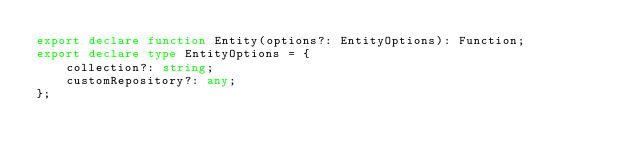<code> <loc_0><loc_0><loc_500><loc_500><_TypeScript_>export declare function Entity(options?: EntityOptions): Function;
export declare type EntityOptions = {
    collection?: string;
    customRepository?: any;
};
</code> 